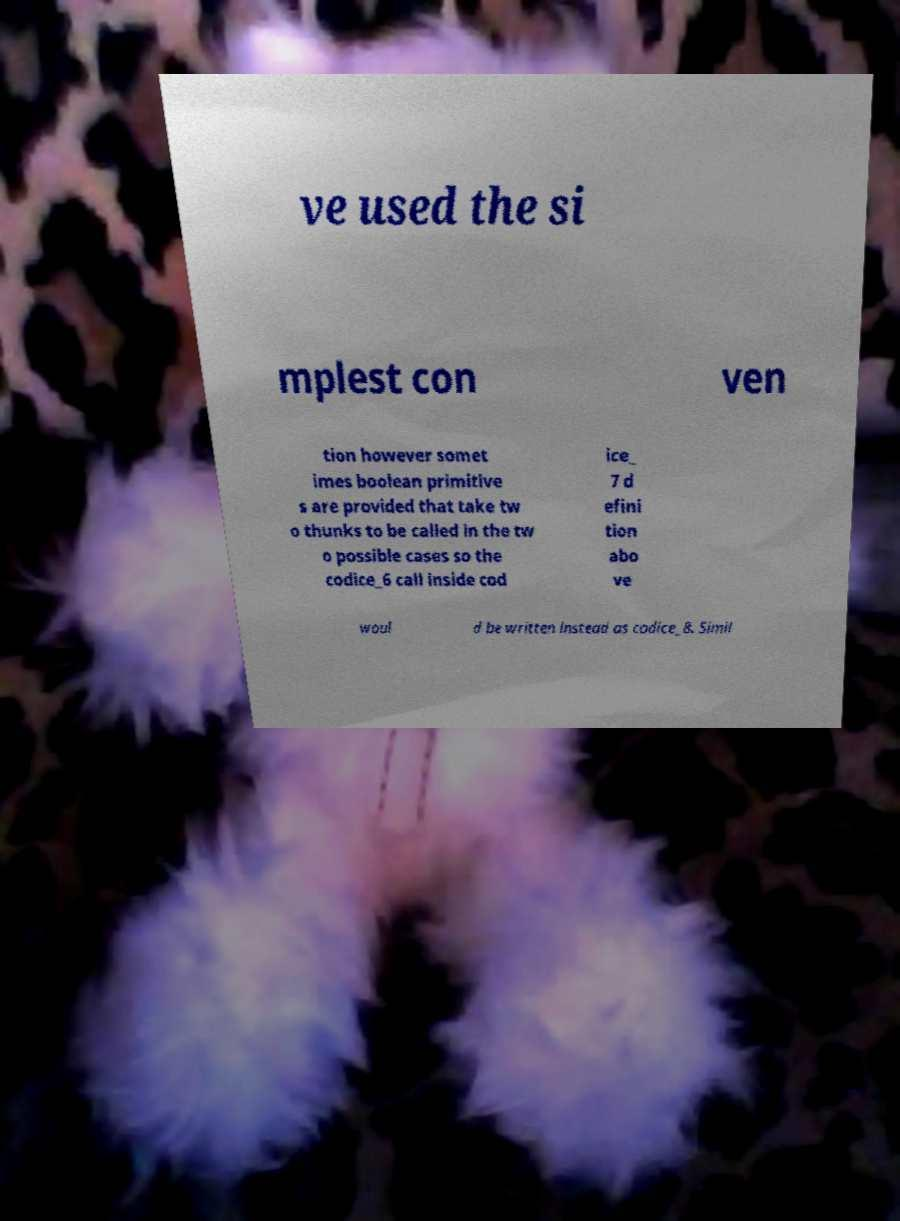Could you assist in decoding the text presented in this image and type it out clearly? ve used the si mplest con ven tion however somet imes boolean primitive s are provided that take tw o thunks to be called in the tw o possible cases so the codice_6 call inside cod ice_ 7 d efini tion abo ve woul d be written instead as codice_8. Simil 